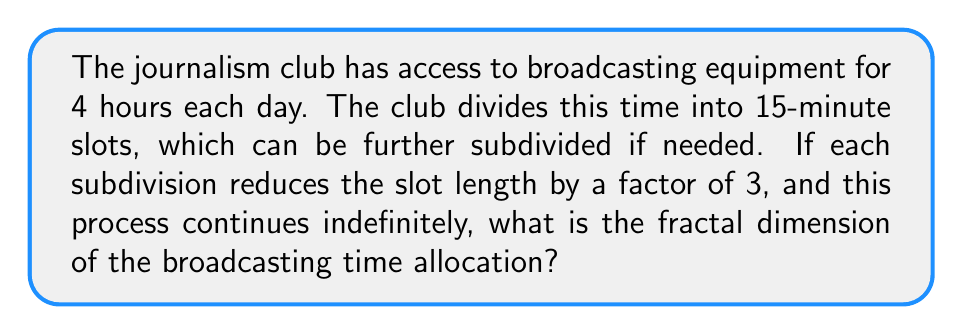Could you help me with this problem? To solve this problem, we'll use the concept of self-similarity and the box-counting method to determine the fractal dimension.

Step 1: Identify the scaling factor
The scaling factor is 3, as each subdivision reduces the slot length by a factor of 3.

Step 2: Determine the number of new pieces created in each subdivision
Each 15-minute slot is divided into 3 smaller slots.

Step 3: Apply the fractal dimension formula
The fractal dimension $D$ is given by the formula:

$$D = \frac{\log N}{\log(1/r)}$$

Where:
$N$ = number of new pieces
$r$ = scaling factor

Step 4: Substitute the values
$N = 3$ (3 new pieces created)
$r = 1/3$ (scaling factor)

$$D = \frac{\log 3}{\log(1/(1/3))} = \frac{\log 3}{\log 3} = 1$$

Therefore, the fractal dimension of the broadcasting time allocation is 1.
Answer: 1 